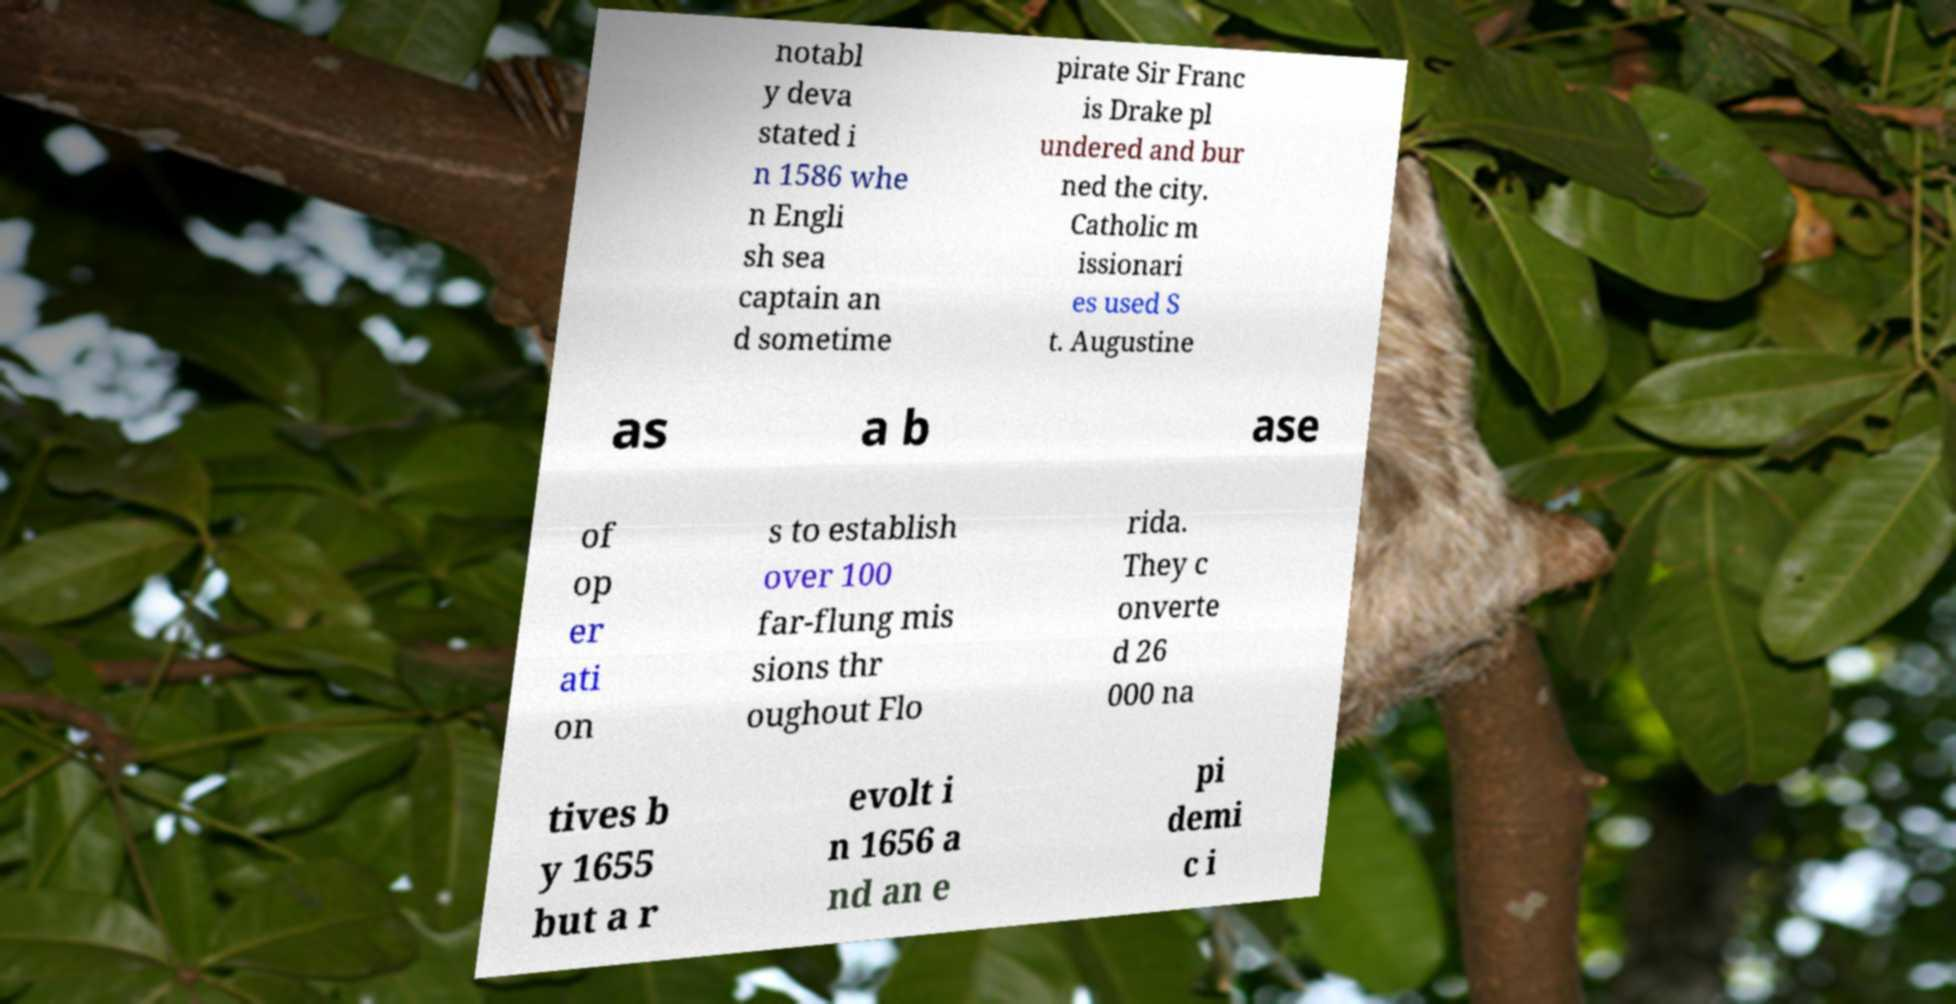Please read and relay the text visible in this image. What does it say? notabl y deva stated i n 1586 whe n Engli sh sea captain an d sometime pirate Sir Franc is Drake pl undered and bur ned the city. Catholic m issionari es used S t. Augustine as a b ase of op er ati on s to establish over 100 far-flung mis sions thr oughout Flo rida. They c onverte d 26 000 na tives b y 1655 but a r evolt i n 1656 a nd an e pi demi c i 